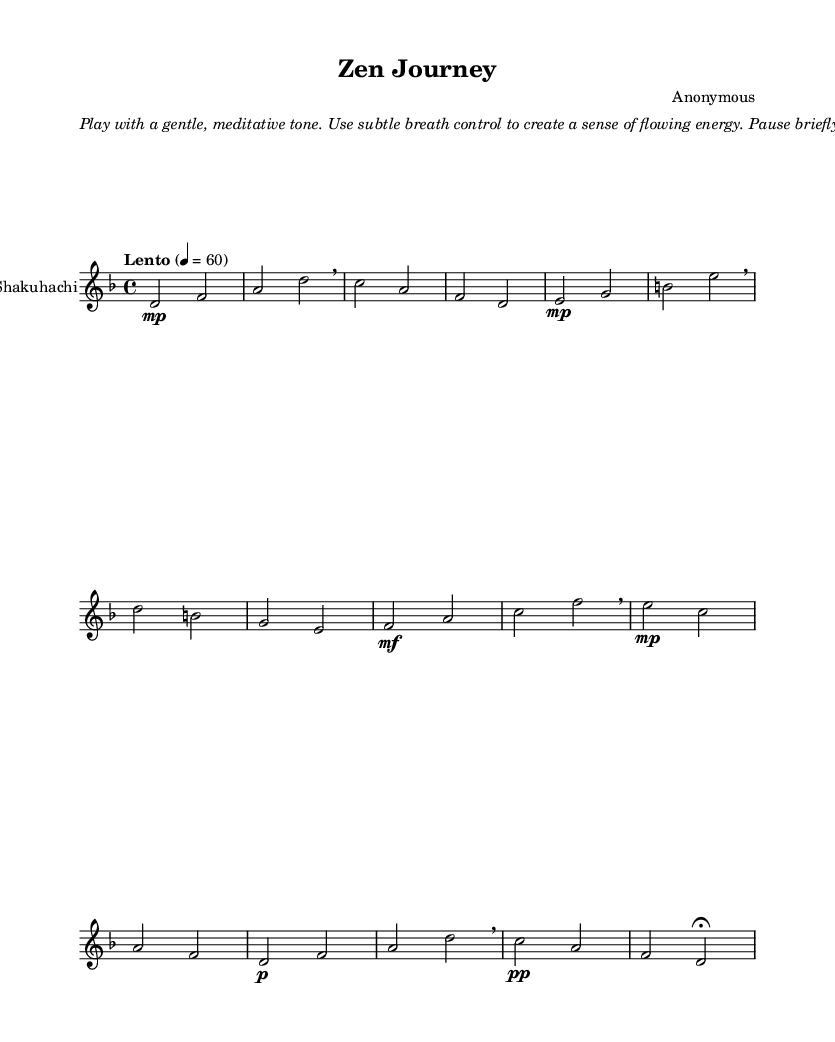What is the key signature of this music? The key signature is indicated at the beginning of the staff. In this case, it shows one flat, which corresponds to D minor.
Answer: D minor What is the time signature of this music? The time signature is represented at the beginning of the sheet music. Here, it shows a '4/4' time signature, meaning there are four beats in each measure.
Answer: 4/4 What tempo marking is given for this piece? The tempo marking is located at the beginning of the score. It specifies "Lento," which indicates a slow tempo, usually around 60 beats per minute.
Answer: Lento How many measures are in the piece? To find the number of measures, count each set of notes or rests separated by bar lines in the music. The visible measures total eight.
Answer: 8 What dynamic marking is used for the first phrase? The dynamic marking near the start of the music indicates the volume of the notes. The first phrase has a marking of "mp," which stands for "mezzo-piano," meaning moderately soft.
Answer: mp What note value is primarily used throughout this piece? Observing the notes, the primary note values in this piece are half notes and quarter notes, with a regular use of half notes occupying each beat.
Answer: Half notes What is the notation for the final note in the piece? The last note in the piece is signified with a "fermata," which indicates that the performer should hold the note longer than its usual value. This marking is located at the end of the last measure.
Answer: Fermata 